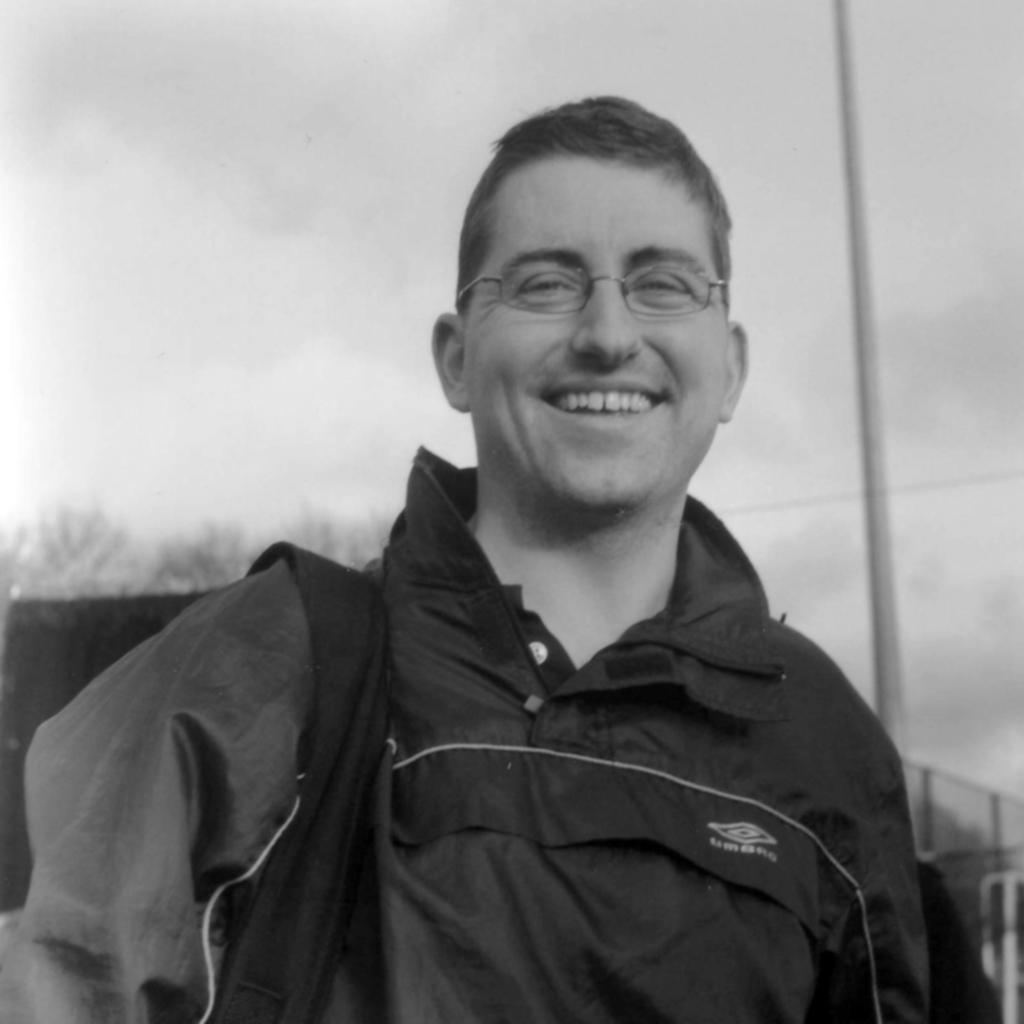What is the main subject in the foreground of the image? There is a man in the foreground of the image. What is the man wearing that resembles a bag? The man appears to be wearing a bag. What can be seen on the right side of the image in the background? There is a pole on the right side of the image in the background. What type of natural scenery is visible in the background of the image? There are trees and the sky visible in the background of the image. Can you see any feathers floating in the soup in the image? There is no soup or feathers present in the image. What type of tail is attached to the man in the image? There is no tail attached to the man in the image. 